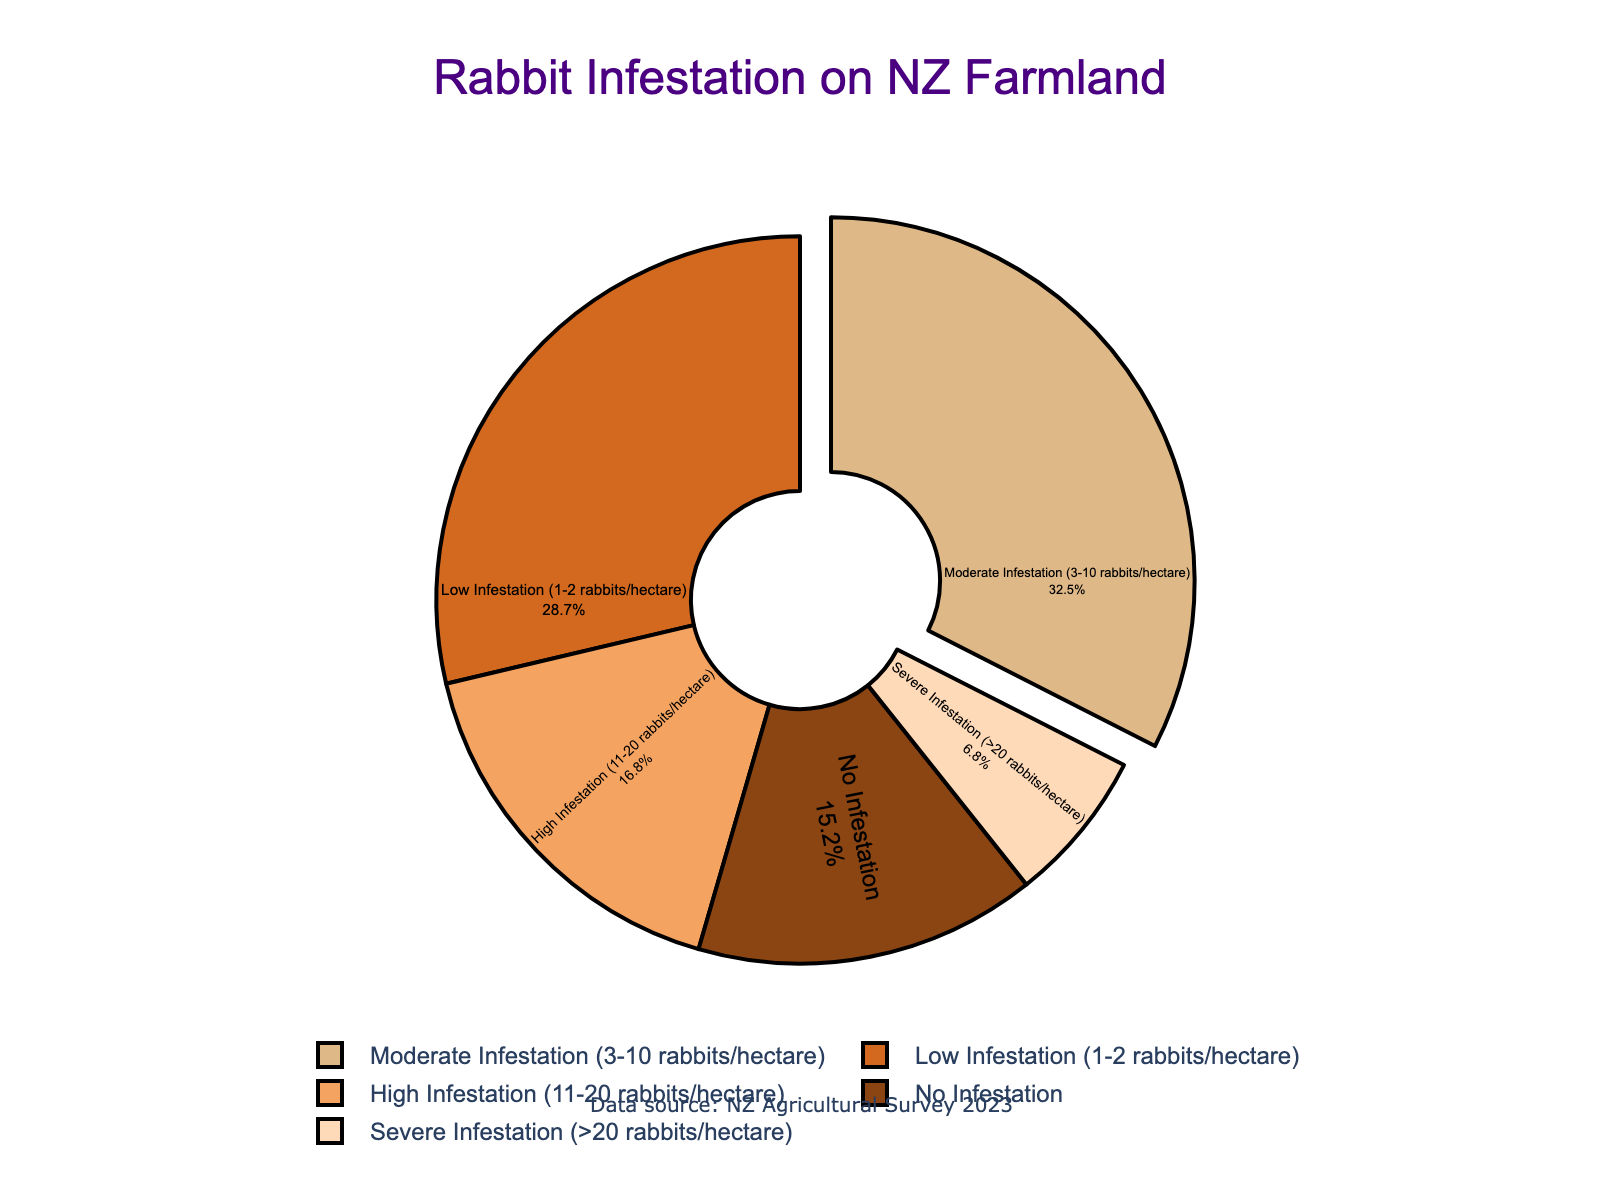what is the percentage of farmland with high infestation levels? To find this, look at the chart segment labeled "High Infestation (11-20 rabbits/hectare)" and read off the corresponding percentage.
Answer: 16.8% which infestation level impacts the largest percentage of farmland? Identify the largest segment in the pie chart. The "Moderate Infestation (3-10 rabbits/hectare)" section is the largest.
Answer: Moderate Infestation (3-10 rabbits/hectare) how much more farmland is moderately infested compared to severely infested? Find the percentages for moderate and severe infestations and compute the difference: 32.5% (moderate) - 6.8% (severe).
Answer: 25.7% which has a greater percentage, low infestation or no infestation? Compare the two percentages: 28.7% for low infestation and 15.2% for no infestation.
Answer: Low Infestation what's the sum of farmland impacted by low, moderate, and high infestations? Add the percentages for low, moderate, and high infestations: 28.7% + 32.5% + 16.8%.
Answer: 78% which section of the pie chart is colored the lightest brown? The section of the pie chart denoting "No Infestation" is the lightest brown.
Answer: No Infestation compare the percentage of farmland with no infestation to that with severe infestation. which is higher? Compare 15.2% (No Infestation) and 6.8% (Severe Infestation) and determine which is greater.
Answer: No Infestation how is the largest segment visually highlighted in the pie chart? Observe that the largest segment, "Moderate Infestation (3-10 rabbits/hectare)", is pulled out slightly from the pie chart.
Answer: Pulled out what proportion of farmland has an infestation (low, moderate, high, or severe)? Subtract the percentage of no infestation from 100%: 100% - 15.2%.
Answer: 84.8% how does the visual position of the text in high infestation differ from the text in no infestation? The text in the "High Infestation" section is positioned inside the segment, similar to other sections.
Answer: No difference in position 